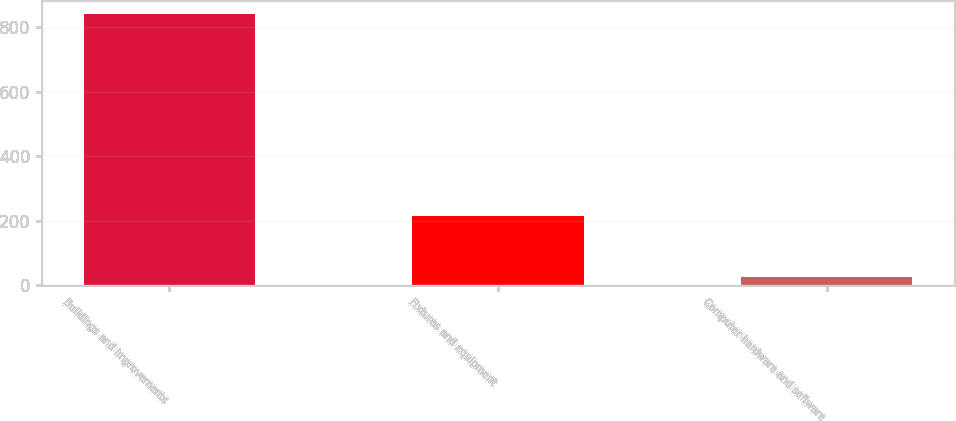<chart> <loc_0><loc_0><loc_500><loc_500><bar_chart><fcel>Buildings and improvements<fcel>Fixtures and equipment<fcel>Computer hardware and software<nl><fcel>839<fcel>215<fcel>27<nl></chart> 